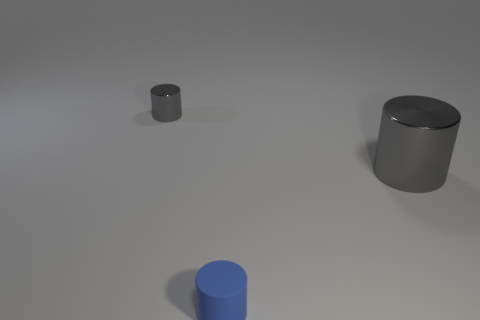Subtract all shiny cylinders. How many cylinders are left? 1 Add 1 big blue matte balls. How many objects exist? 4 Subtract all large gray cylinders. Subtract all small shiny cylinders. How many objects are left? 1 Add 1 tiny blue cylinders. How many tiny blue cylinders are left? 2 Add 1 blue shiny cylinders. How many blue shiny cylinders exist? 1 Subtract all gray cylinders. How many cylinders are left? 1 Subtract 0 brown balls. How many objects are left? 3 Subtract 1 cylinders. How many cylinders are left? 2 Subtract all yellow cylinders. Subtract all green balls. How many cylinders are left? 3 Subtract all cyan spheres. How many purple cylinders are left? 0 